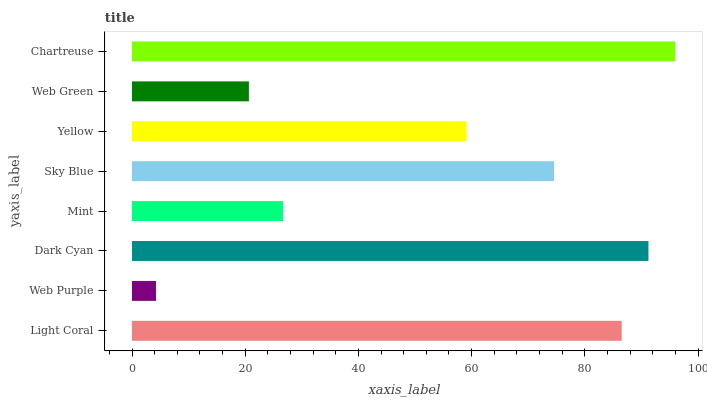Is Web Purple the minimum?
Answer yes or no. Yes. Is Chartreuse the maximum?
Answer yes or no. Yes. Is Dark Cyan the minimum?
Answer yes or no. No. Is Dark Cyan the maximum?
Answer yes or no. No. Is Dark Cyan greater than Web Purple?
Answer yes or no. Yes. Is Web Purple less than Dark Cyan?
Answer yes or no. Yes. Is Web Purple greater than Dark Cyan?
Answer yes or no. No. Is Dark Cyan less than Web Purple?
Answer yes or no. No. Is Sky Blue the high median?
Answer yes or no. Yes. Is Yellow the low median?
Answer yes or no. Yes. Is Light Coral the high median?
Answer yes or no. No. Is Web Green the low median?
Answer yes or no. No. 